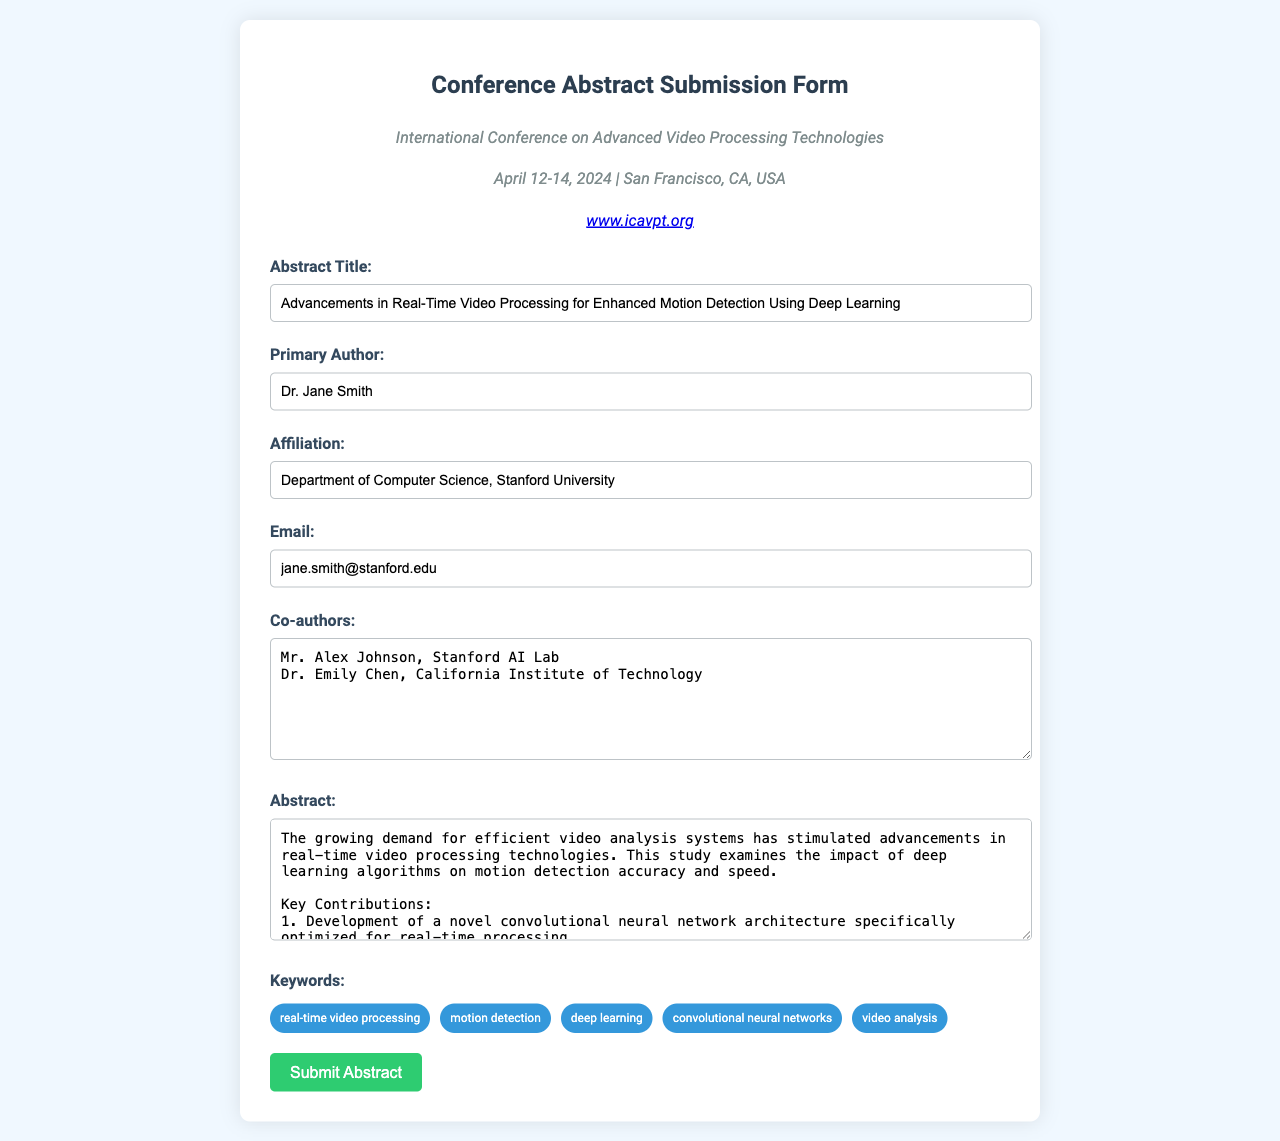What is the title of the abstract? The title is stated in the form's title field.
Answer: Advancements in Real-Time Video Processing for Enhanced Motion Detection Using Deep Learning Who is the primary author? The primary author is listed in the form under the author's section.
Answer: Dr. Jane Smith What institution is the primary author affiliated with? The affiliation is mentioned in the form under the affiliation field.
Answer: Department of Computer Science, Stanford University What is the submission deadline for the conference? The document indicates the date of the conference which indirectly suggests the deadline.
Answer: April 14, 2024 What is one of the key contributions mentioned in the abstract? Key contributions are listed in the abstract section of the form.
Answer: Development of a novel convolutional neural network architecture How much improvement in processing speed does the research claim? The improvement in processing speed is quantified in the abstract.
Answer: 30% What are the implications of the research mentioned in the abstract? Implications are provided in the abstract detailing the impact of the contributions.
Answer: Applications in security and surveillance What method is emphasized for enhancing motion detection capabilities? The abstract outlines the method used for enhancements.
Answer: Integration of temporal and spatial features How many keywords are listed in the document? The number of keywords is identified by counting the keywords mentioned.
Answer: Five 